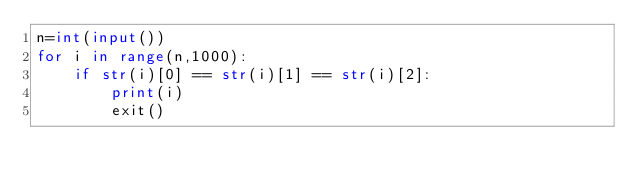Convert code to text. <code><loc_0><loc_0><loc_500><loc_500><_Python_>n=int(input())
for i in range(n,1000):
    if str(i)[0] == str(i)[1] == str(i)[2]:
        print(i)
        exit()</code> 